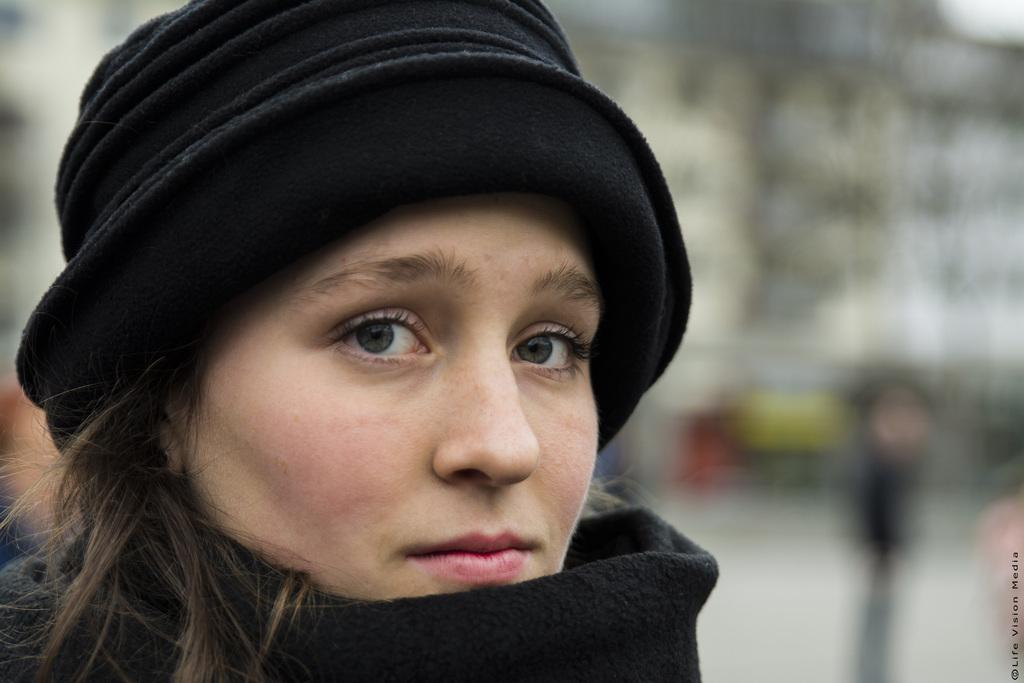Who is present in the image? There is a woman in the image. What is the woman wearing on her head? The woman is wearing a cap. What type of apparatus is the woman using to crack an egg in the image? There is no apparatus or egg present in the image; it only features a woman wearing a cap. 